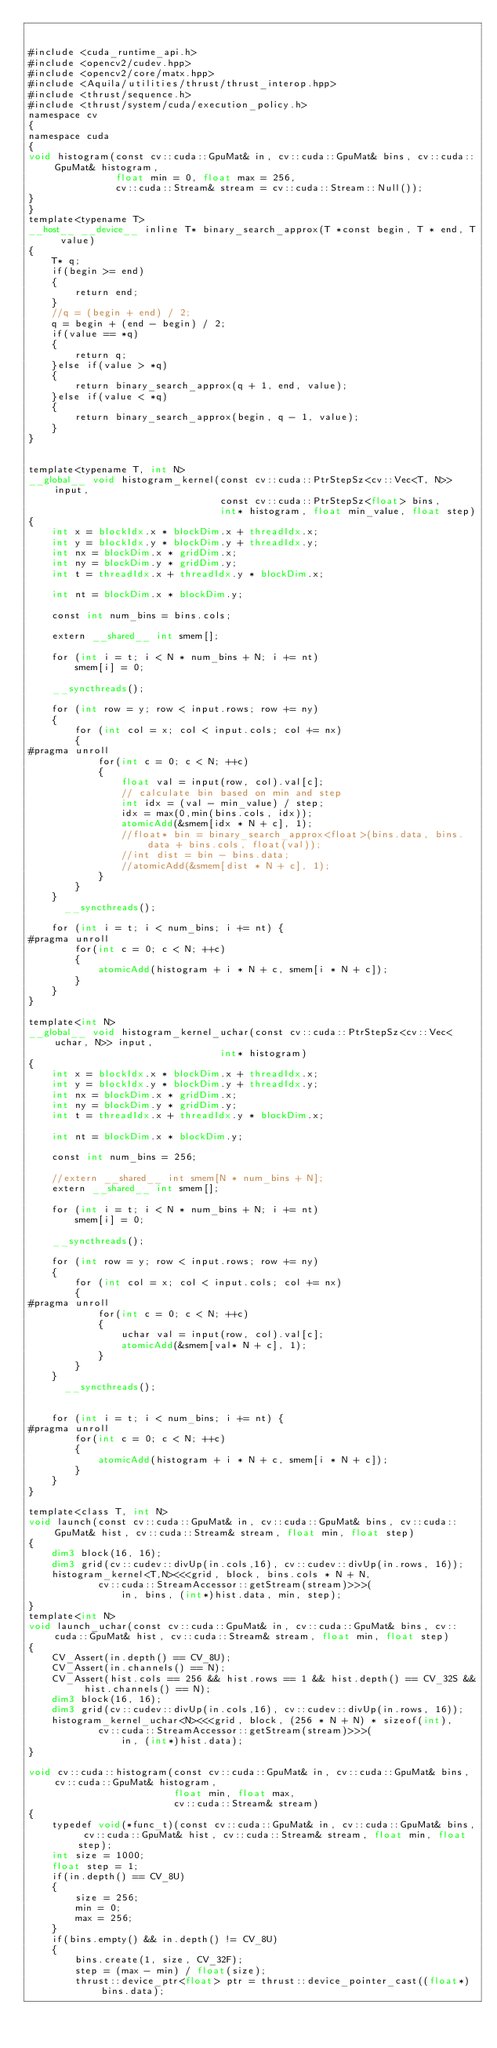<code> <loc_0><loc_0><loc_500><loc_500><_Cuda_>

#include <cuda_runtime_api.h>
#include <opencv2/cudev.hpp>
#include <opencv2/core/matx.hpp>
#include <Aquila/utilities/thrust/thrust_interop.hpp>
#include <thrust/sequence.h>
#include <thrust/system/cuda/execution_policy.h>
namespace cv
{
namespace cuda
{
void histogram(const cv::cuda::GpuMat& in, cv::cuda::GpuMat& bins, cv::cuda::GpuMat& histogram,
               float min = 0, float max = 256,
               cv::cuda::Stream& stream = cv::cuda::Stream::Null());
}
}
template<typename T>
__host__ __device__ inline T* binary_search_approx(T *const begin, T * end, T value)
{
    T* q;
    if(begin >= end)
    {
        return end;
    }
    //q = (begin + end) / 2;
    q = begin + (end - begin) / 2;
    if(value == *q)
    {
        return q;
    }else if(value > *q)
    {
        return binary_search_approx(q + 1, end, value);
    }else if(value < *q)
    {
        return binary_search_approx(begin, q - 1, value);
    }
}


template<typename T, int N>
__global__ void histogram_kernel(const cv::cuda::PtrStepSz<cv::Vec<T, N>> input,
                                 const cv::cuda::PtrStepSz<float> bins,
                                 int* histogram, float min_value, float step)
{
    int x = blockIdx.x * blockDim.x + threadIdx.x;
    int y = blockIdx.y * blockDim.y + threadIdx.y;
    int nx = blockDim.x * gridDim.x;
    int ny = blockDim.y * gridDim.y;
    int t = threadIdx.x + threadIdx.y * blockDim.x;

    int nt = blockDim.x * blockDim.y;

    const int num_bins = bins.cols;

    extern __shared__ int smem[];

    for (int i = t; i < N * num_bins + N; i += nt)
        smem[i] = 0;

    __syncthreads();

    for (int row = y; row < input.rows; row += ny)
    {
        for (int col = x; col < input.cols; col += nx)
        {
#pragma unroll
            for(int c = 0; c < N; ++c)
            {
                float val = input(row, col).val[c];
                // calculate bin based on min and step
                int idx = (val - min_value) / step;
                idx = max(0,min(bins.cols, idx));
                atomicAdd(&smem[idx * N + c], 1);
                //float* bin = binary_search_approx<float>(bins.data, bins.data + bins.cols, float(val));
                //int dist = bin - bins.data;
                //atomicAdd(&smem[dist * N + c], 1);
            }
        }
    }
      __syncthreads();

    for (int i = t; i < num_bins; i += nt) {
#pragma unroll
        for(int c = 0; c < N; ++c)
        {
            atomicAdd(histogram + i * N + c, smem[i * N + c]);
        }
    }
}

template<int N>
__global__ void histogram_kernel_uchar(const cv::cuda::PtrStepSz<cv::Vec<uchar, N>> input,
                                 int* histogram)
{
    int x = blockIdx.x * blockDim.x + threadIdx.x;
    int y = blockIdx.y * blockDim.y + threadIdx.y;
    int nx = blockDim.x * gridDim.x;
    int ny = blockDim.y * gridDim.y;
    int t = threadIdx.x + threadIdx.y * blockDim.x;

    int nt = blockDim.x * blockDim.y;

    const int num_bins = 256;

    //extern __shared__ int smem[N * num_bins + N];
    extern __shared__ int smem[];

    for (int i = t; i < N * num_bins + N; i += nt)
        smem[i] = 0;

    __syncthreads();

    for (int row = y; row < input.rows; row += ny)
    {
        for (int col = x; col < input.cols; col += nx)
        {
#pragma unroll
            for(int c = 0; c < N; ++c)
            {
                uchar val = input(row, col).val[c];
                atomicAdd(&smem[val* N + c], 1);
            }
        }
    }
      __syncthreads();


    for (int i = t; i < num_bins; i += nt) {
#pragma unroll
        for(int c = 0; c < N; ++c)
        {
            atomicAdd(histogram + i * N + c, smem[i * N + c]);
        }
    }
}

template<class T, int N>
void launch(const cv::cuda::GpuMat& in, cv::cuda::GpuMat& bins, cv::cuda::GpuMat& hist, cv::cuda::Stream& stream, float min, float step)
{
    dim3 block(16, 16);
    dim3 grid(cv::cudev::divUp(in.cols,16), cv::cudev::divUp(in.rows, 16));
    histogram_kernel<T,N><<<grid, block, bins.cols * N + N,
            cv::cuda::StreamAccessor::getStream(stream)>>>(
                in, bins, (int*)hist.data, min, step);
}
template<int N>
void launch_uchar(const cv::cuda::GpuMat& in, cv::cuda::GpuMat& bins, cv::cuda::GpuMat& hist, cv::cuda::Stream& stream, float min, float step)
{
    CV_Assert(in.depth() == CV_8U);
    CV_Assert(in.channels() == N);
    CV_Assert(hist.cols == 256 && hist.rows == 1 && hist.depth() == CV_32S && hist.channels() == N);
    dim3 block(16, 16);
    dim3 grid(cv::cudev::divUp(in.cols,16), cv::cudev::divUp(in.rows, 16));
    histogram_kernel_uchar<N><<<grid, block, (256 * N + N) * sizeof(int),
            cv::cuda::StreamAccessor::getStream(stream)>>>(
                in, (int*)hist.data);
}

void cv::cuda::histogram(const cv::cuda::GpuMat& in, cv::cuda::GpuMat& bins, cv::cuda::GpuMat& histogram,
                         float min, float max,
                         cv::cuda::Stream& stream)
{
    typedef void(*func_t)(const cv::cuda::GpuMat& in, cv::cuda::GpuMat& bins, cv::cuda::GpuMat& hist, cv::cuda::Stream& stream, float min, float step);
    int size = 1000;
    float step = 1;
    if(in.depth() == CV_8U)
    {
        size = 256;
        min = 0;
        max = 256;
    }
    if(bins.empty() && in.depth() != CV_8U)
    {
        bins.create(1, size, CV_32F);
        step = (max - min) / float(size);
        thrust::device_ptr<float> ptr = thrust::device_pointer_cast((float*)bins.data);</code> 